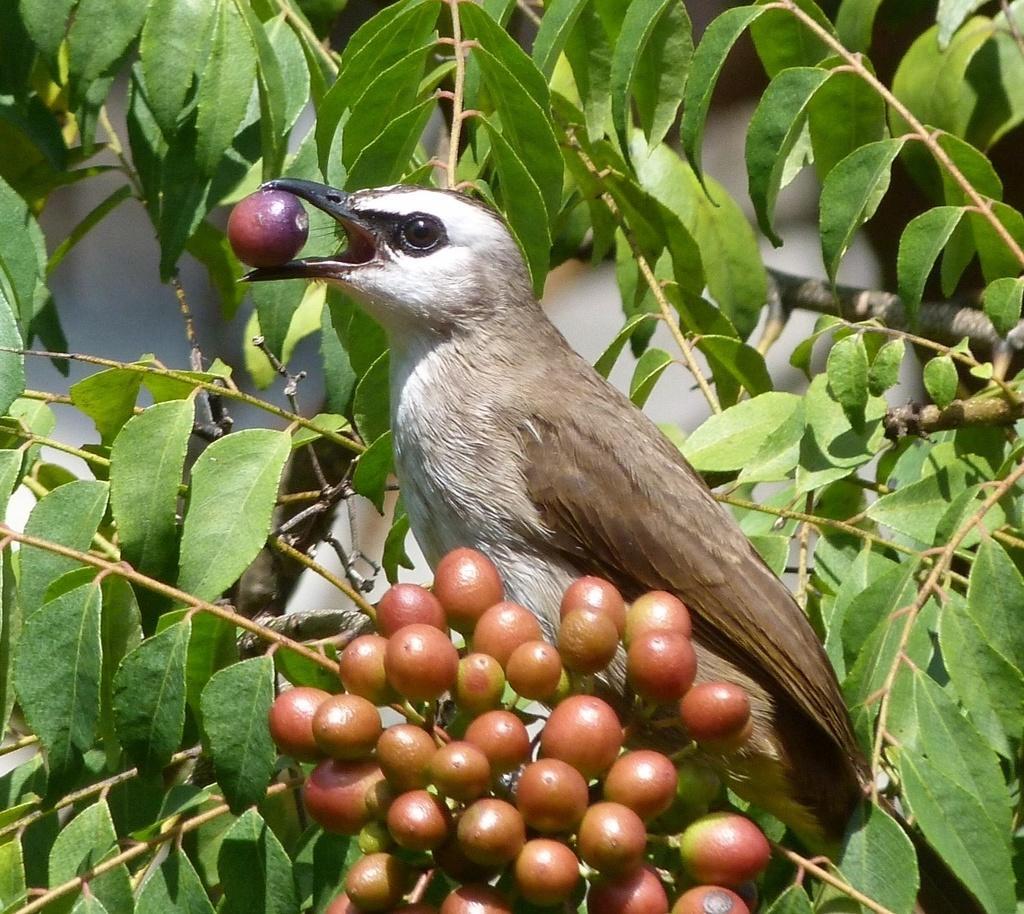Could you give a brief overview of what you see in this image? In this image I can see a bird sitting on a tree branch with fruits holding a fruit in her mouth. 